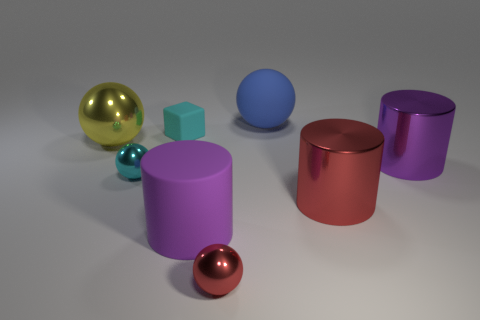Are there any other things that are the same size as the matte ball?
Offer a terse response. Yes. There is a red ball; is its size the same as the rubber thing that is in front of the yellow object?
Ensure brevity in your answer.  No. What number of purple matte objects are there?
Provide a short and direct response. 1. There is a purple cylinder that is behind the tiny cyan metallic sphere; is it the same size as the red metallic object right of the red shiny ball?
Offer a terse response. Yes. What is the color of the other small shiny object that is the same shape as the tiny cyan metallic object?
Offer a terse response. Red. Does the large red thing have the same shape as the blue object?
Ensure brevity in your answer.  No. What is the size of the red metal object that is the same shape as the big yellow metallic object?
Offer a very short reply. Small. What number of red cylinders have the same material as the big red object?
Offer a very short reply. 0. What number of objects are cyan objects or yellow things?
Make the answer very short. 3. There is a big shiny object that is in front of the purple shiny object; are there any tiny red metal things left of it?
Offer a very short reply. Yes. 